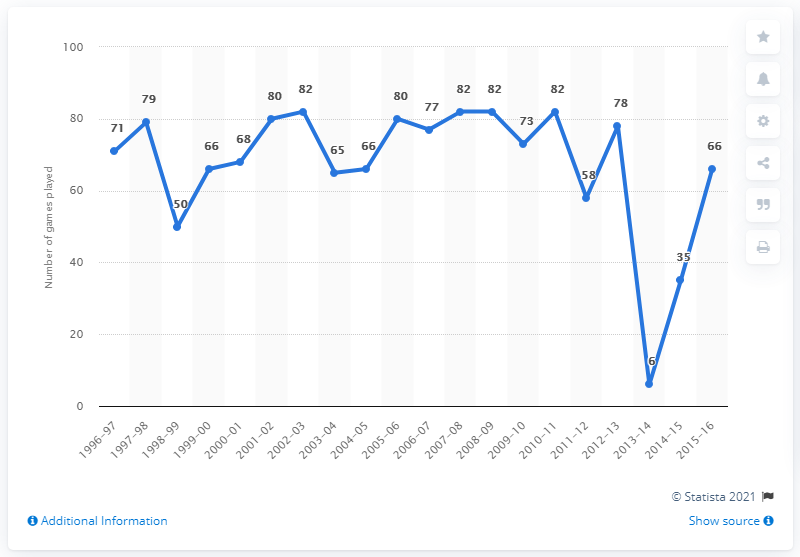Indicate a few pertinent items in this graphic. In the 2013-2014 season, the number of games played was greater than in the 2012-2013 season by 72 games. In total, 20 years have been considered. 